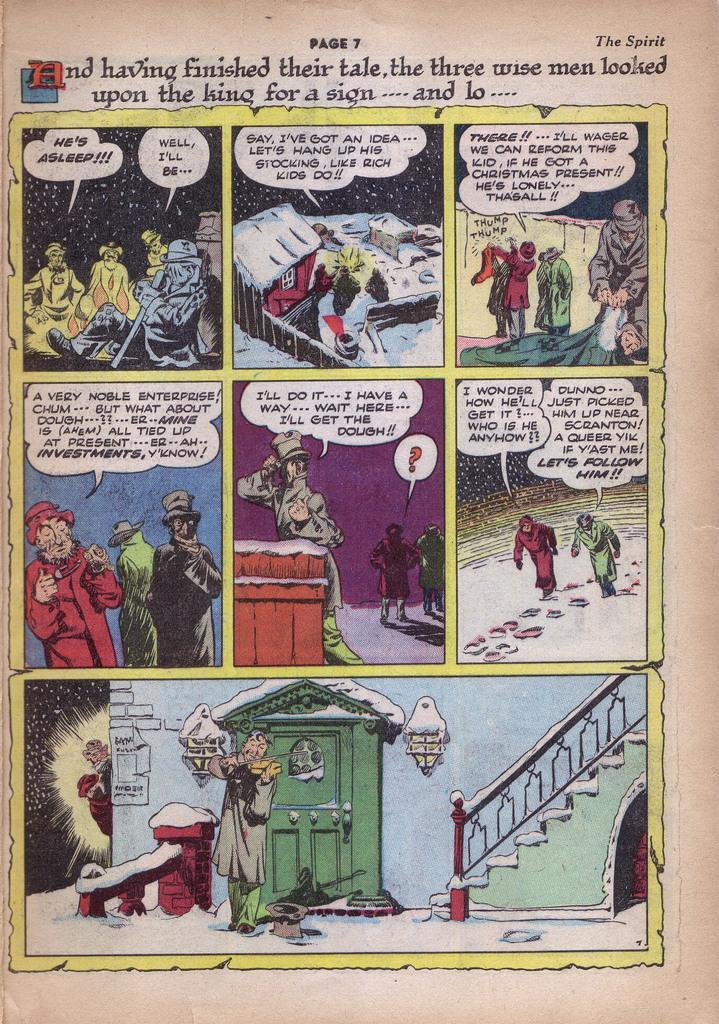<image>
Render a clear and concise summary of the photo. a page that says 'and having finished their tale...' on the top of it 